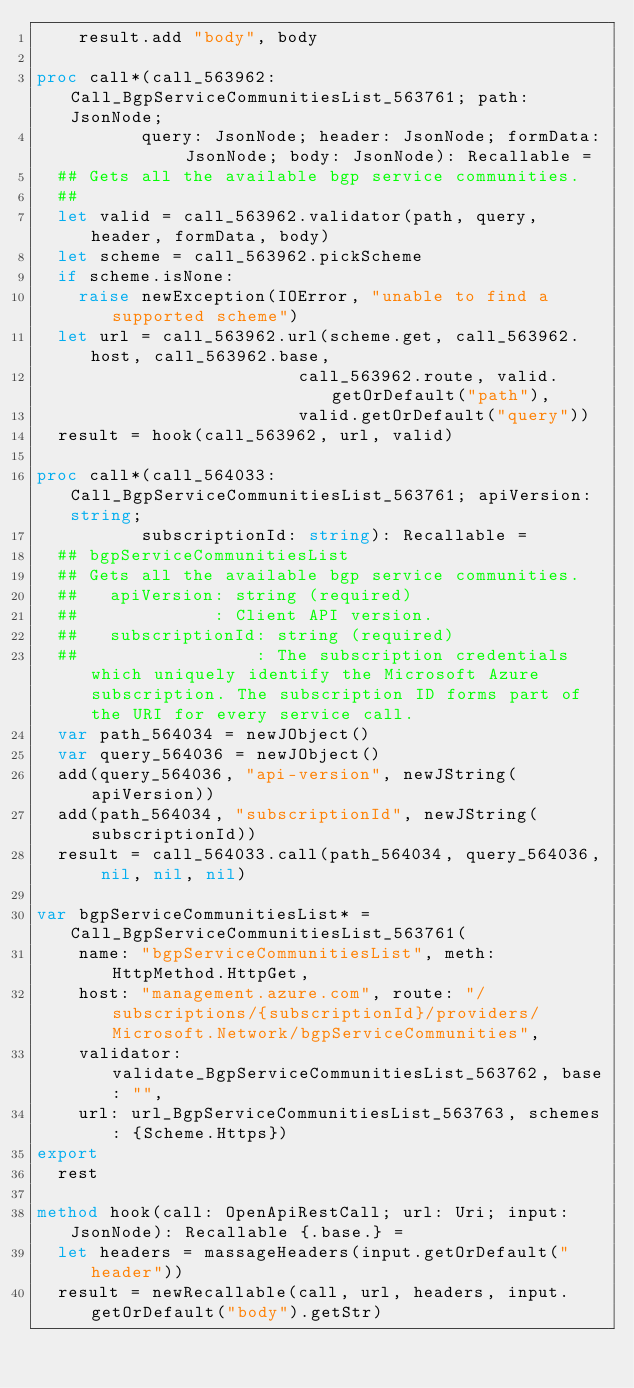<code> <loc_0><loc_0><loc_500><loc_500><_Nim_>    result.add "body", body

proc call*(call_563962: Call_BgpServiceCommunitiesList_563761; path: JsonNode;
          query: JsonNode; header: JsonNode; formData: JsonNode; body: JsonNode): Recallable =
  ## Gets all the available bgp service communities.
  ## 
  let valid = call_563962.validator(path, query, header, formData, body)
  let scheme = call_563962.pickScheme
  if scheme.isNone:
    raise newException(IOError, "unable to find a supported scheme")
  let url = call_563962.url(scheme.get, call_563962.host, call_563962.base,
                         call_563962.route, valid.getOrDefault("path"),
                         valid.getOrDefault("query"))
  result = hook(call_563962, url, valid)

proc call*(call_564033: Call_BgpServiceCommunitiesList_563761; apiVersion: string;
          subscriptionId: string): Recallable =
  ## bgpServiceCommunitiesList
  ## Gets all the available bgp service communities.
  ##   apiVersion: string (required)
  ##             : Client API version.
  ##   subscriptionId: string (required)
  ##                 : The subscription credentials which uniquely identify the Microsoft Azure subscription. The subscription ID forms part of the URI for every service call.
  var path_564034 = newJObject()
  var query_564036 = newJObject()
  add(query_564036, "api-version", newJString(apiVersion))
  add(path_564034, "subscriptionId", newJString(subscriptionId))
  result = call_564033.call(path_564034, query_564036, nil, nil, nil)

var bgpServiceCommunitiesList* = Call_BgpServiceCommunitiesList_563761(
    name: "bgpServiceCommunitiesList", meth: HttpMethod.HttpGet,
    host: "management.azure.com", route: "/subscriptions/{subscriptionId}/providers/Microsoft.Network/bgpServiceCommunities",
    validator: validate_BgpServiceCommunitiesList_563762, base: "",
    url: url_BgpServiceCommunitiesList_563763, schemes: {Scheme.Https})
export
  rest

method hook(call: OpenApiRestCall; url: Uri; input: JsonNode): Recallable {.base.} =
  let headers = massageHeaders(input.getOrDefault("header"))
  result = newRecallable(call, url, headers, input.getOrDefault("body").getStr)
</code> 